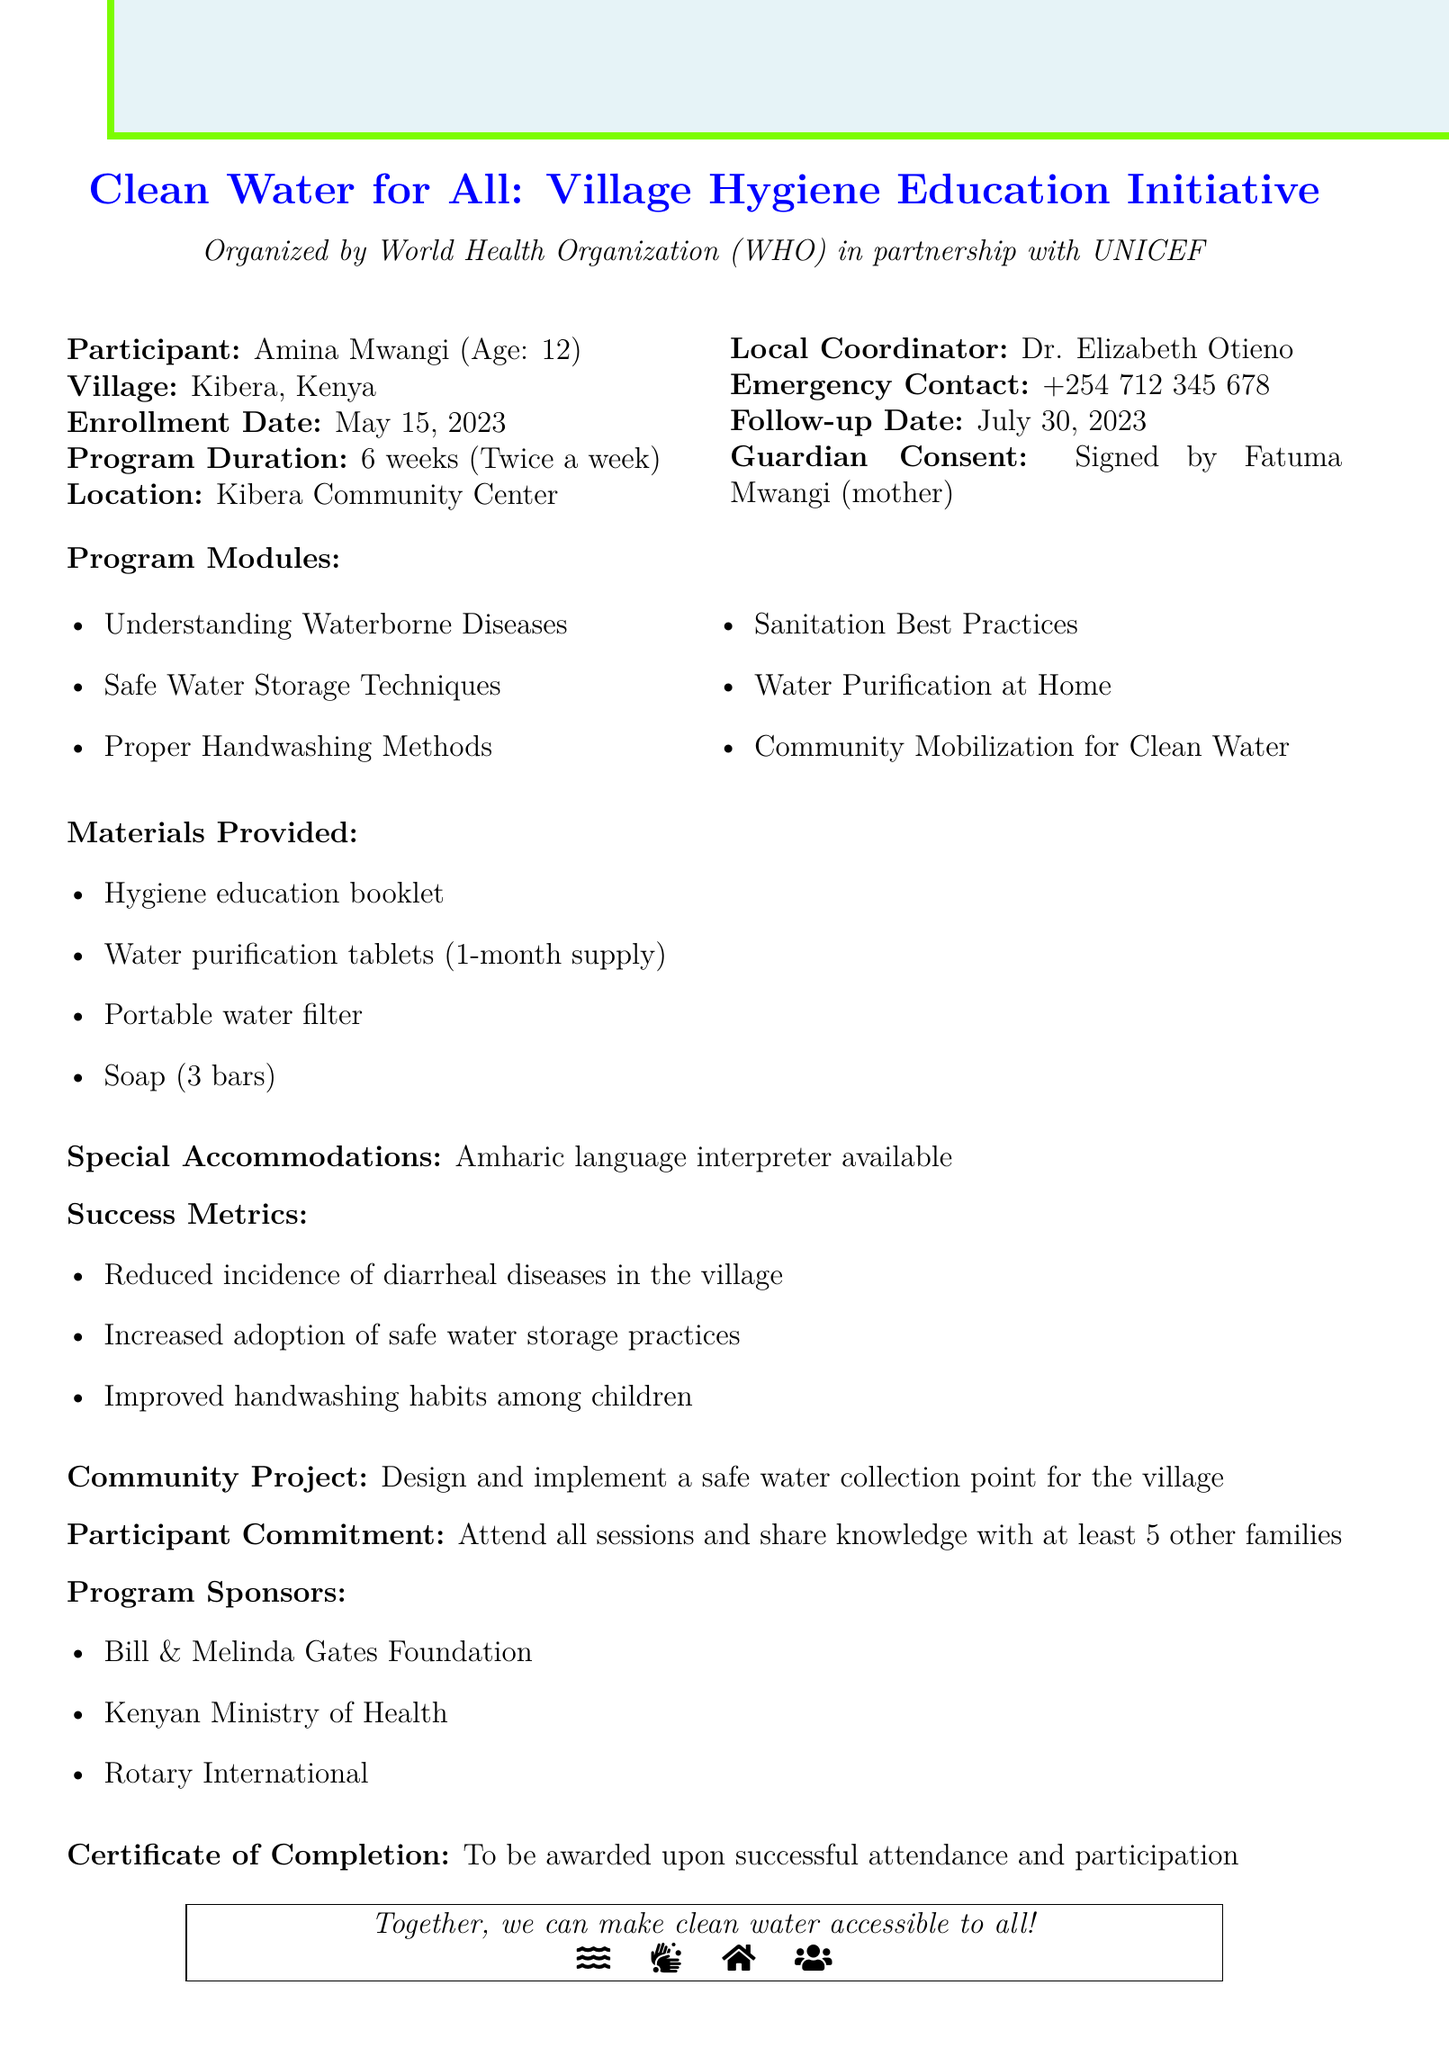what is the program name? The program name is explicitly stated at the beginning of the document, which is "Clean Water for All: Village Hygiene Education Initiative."
Answer: Clean Water for All: Village Hygiene Education Initiative who is the organizing body? The document identifies the organizing body as the "World Health Organization (WHO) in partnership with UNICEF."
Answer: World Health Organization (WHO) in partnership with UNICEF when did Amina Mwangi enroll in the program? The enrollment date for Amina Mwangi is specified in the document as May 15, 2023.
Answer: May 15, 2023 how long is the program's duration? The program duration is mentioned in the document as 6 weeks.
Answer: 6 weeks what materials are provided for the program? A list of materials provided can be found in the document; they include "Hygiene education booklet, Water purification tablets (1-month supply), Portable water filter, Soap (3 bars)."
Answer: Hygiene education booklet, Water purification tablets (1-month supply), Portable water filter, Soap (3 bars) what commitment is expected from participants? The document outlines the participant commitment as attending all sessions and sharing knowledge with at least 5 other families.
Answer: Attend all sessions and share knowledge with at least 5 other families who is the local coordinator for the program? The local coordinator is mentioned specifically in the document as Dr. Elizabeth Otieno.
Answer: Dr. Elizabeth Otieno what is the follow-up date for the program? The follow-up date is clearly stated in the document as July 30, 2023.
Answer: July 30, 2023 